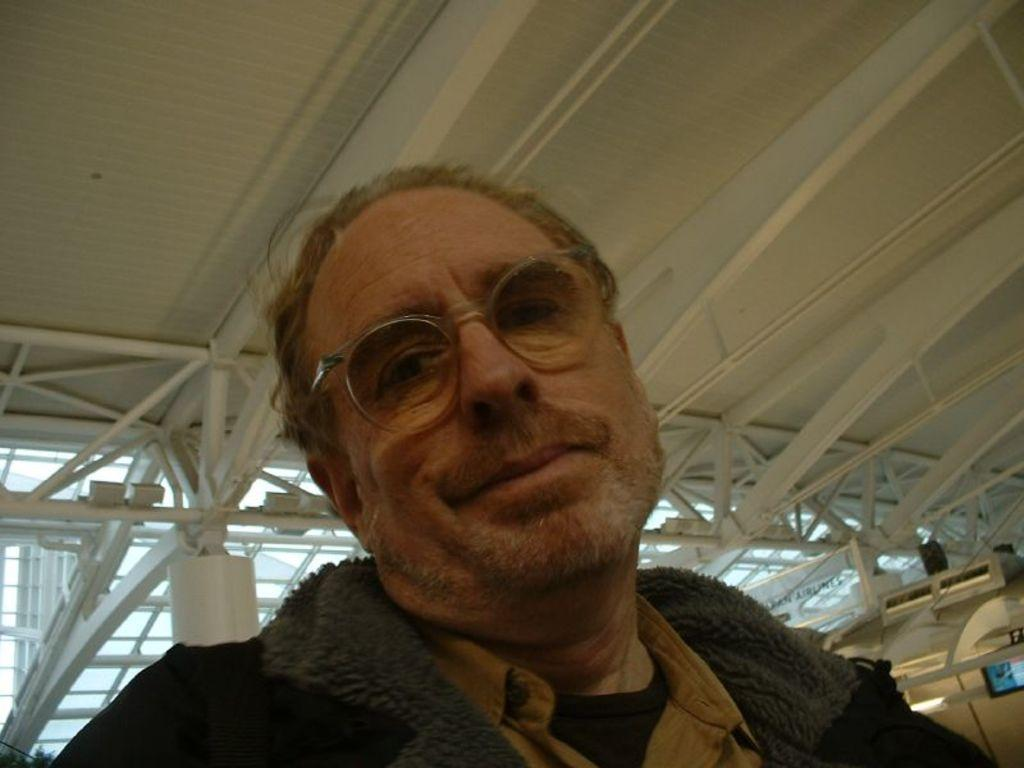Who is the main subject in the image? There is an old man in the image. What is the old man wearing? The old man is wearing a jacket and spectacles. What expression does the old man have? The old man is smiling. What type of ceiling can be seen in the image? There is a metal ceiling in the image. What is the current flowing through the old man's spectacles in the image? There is no indication of a current flowing through the old man's spectacles in the image. 